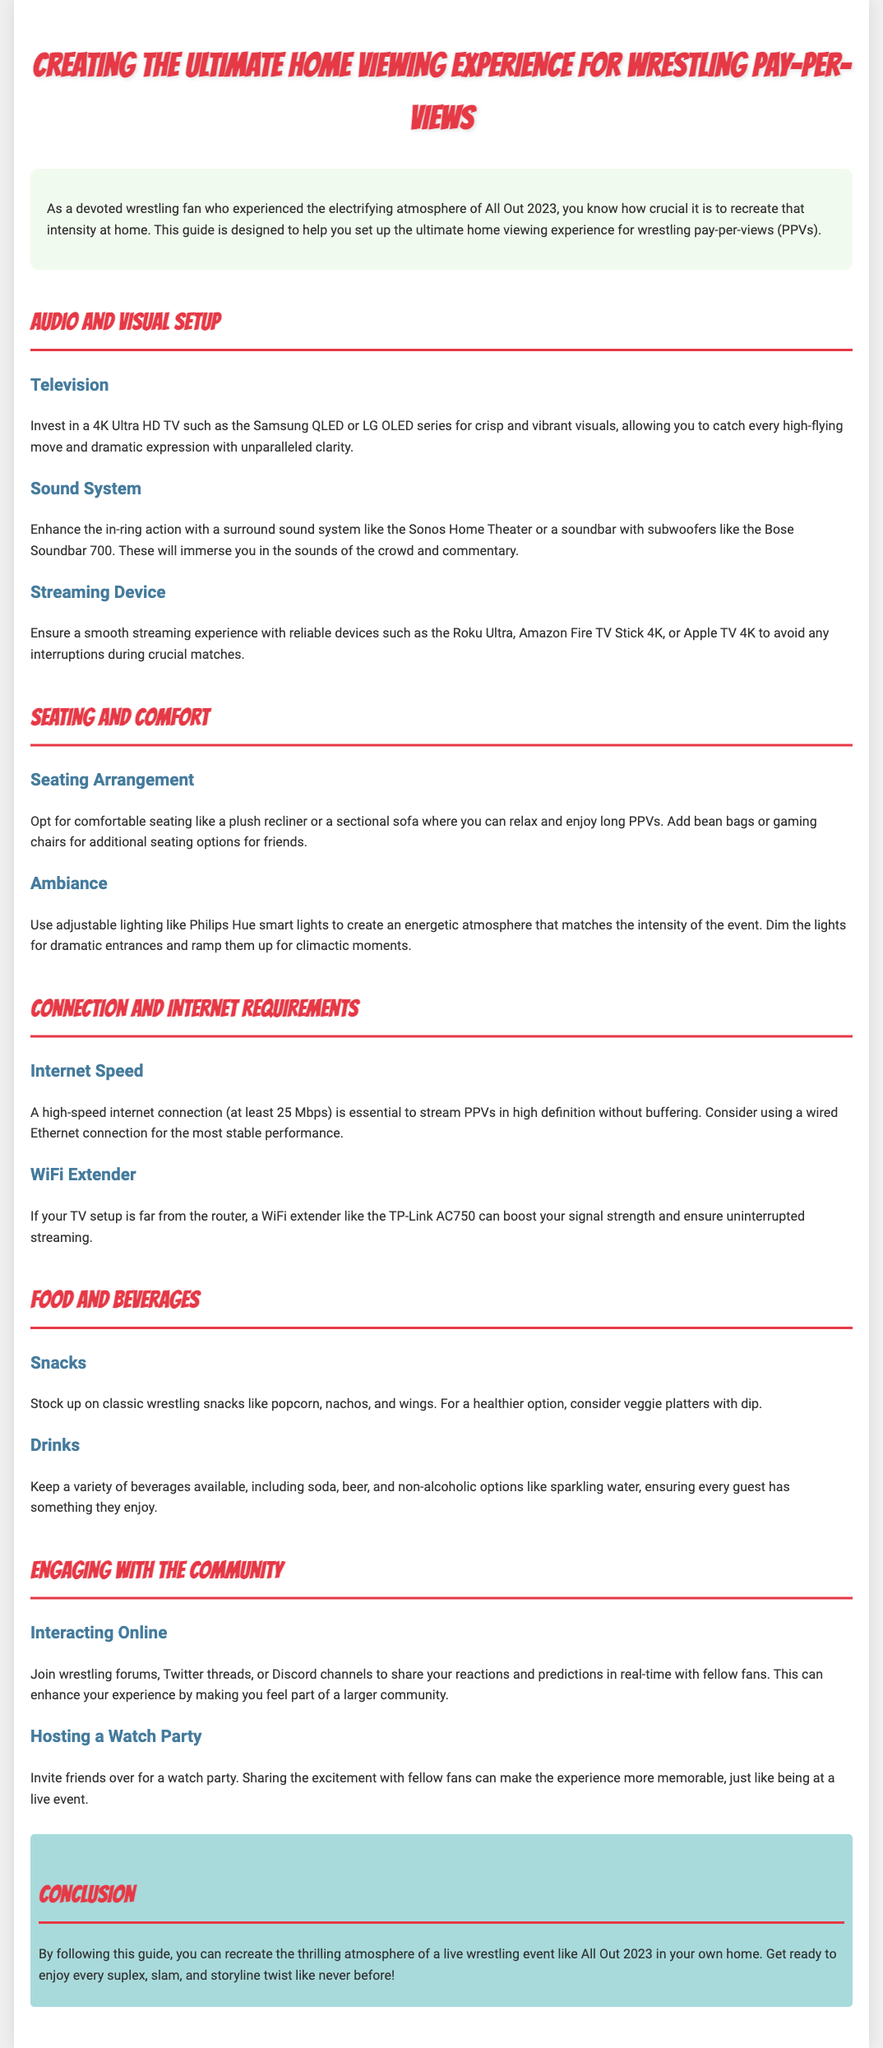what is the recommended TV type for viewing wrestling PPVs? The document specifies that investing in a 4K Ultra HD TV such as the Samsung QLED or LG OLED series is recommended.
Answer: 4K Ultra HD TV what internet speed is essential for streaming PPVs? The guide mentions that a high-speed internet connection of at least 25 Mbps is essential for streaming without buffering.
Answer: 25 Mbps what is a suggested sound system for enhancing the viewing experience? The document recommends using a surround sound system like the Sonos Home Theater or a soundbar with subwoofers like the Bose Soundbar 700.
Answer: Sonos Home Theater what type of lighting is recommended for creating ambiance? The guide suggests using adjustable lighting like Philips Hue smart lights to create an energetic atmosphere.
Answer: Philips Hue smart lights how can viewers engage with the wrestling community? According to the document, viewers can join wrestling forums, Twitter threads, or Discord channels to share their reactions.
Answer: Online interaction what food is suggested for wrestling PPV viewing? The document suggests stocking up on classic wrestling snacks like popcorn, nachos, and wings.
Answer: Popcorn, nachos, wings what is one benefit of hosting a watch party? The guide states that sharing the excitement with fellow fans makes the experience more memorable.
Answer: More memorable experience what device is suggested for a smooth streaming experience? The document recommends reliable devices such as the Roku Ultra, Amazon Fire TV Stick 4K, or Apple TV 4K.
Answer: Roku Ultra what is the purpose of using a WiFi extender? The document explains that a WiFi extender boosts signal strength for uninterrupted streaming if the TV setup is far from the router.
Answer: Boost signal strength 